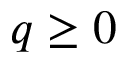Convert formula to latex. <formula><loc_0><loc_0><loc_500><loc_500>q \geq 0</formula> 